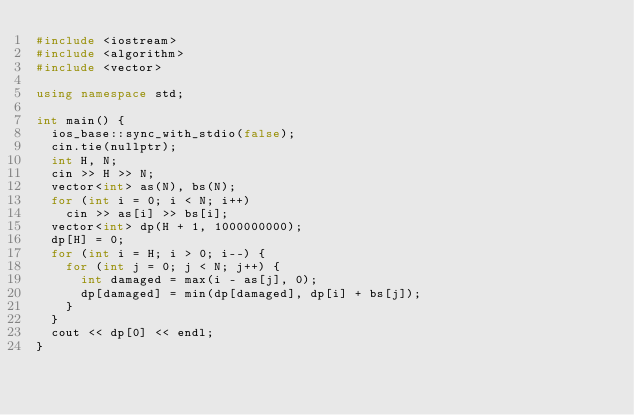<code> <loc_0><loc_0><loc_500><loc_500><_C++_>#include <iostream>
#include <algorithm>
#include <vector>

using namespace std;

int main() {
  ios_base::sync_with_stdio(false);
  cin.tie(nullptr);
  int H, N;
  cin >> H >> N;
  vector<int> as(N), bs(N);
  for (int i = 0; i < N; i++)
    cin >> as[i] >> bs[i];
  vector<int> dp(H + 1, 1000000000);
  dp[H] = 0;
  for (int i = H; i > 0; i--) {
    for (int j = 0; j < N; j++) {
      int damaged = max(i - as[j], 0);
      dp[damaged] = min(dp[damaged], dp[i] + bs[j]);
    }
  }
  cout << dp[0] << endl;
}
</code> 